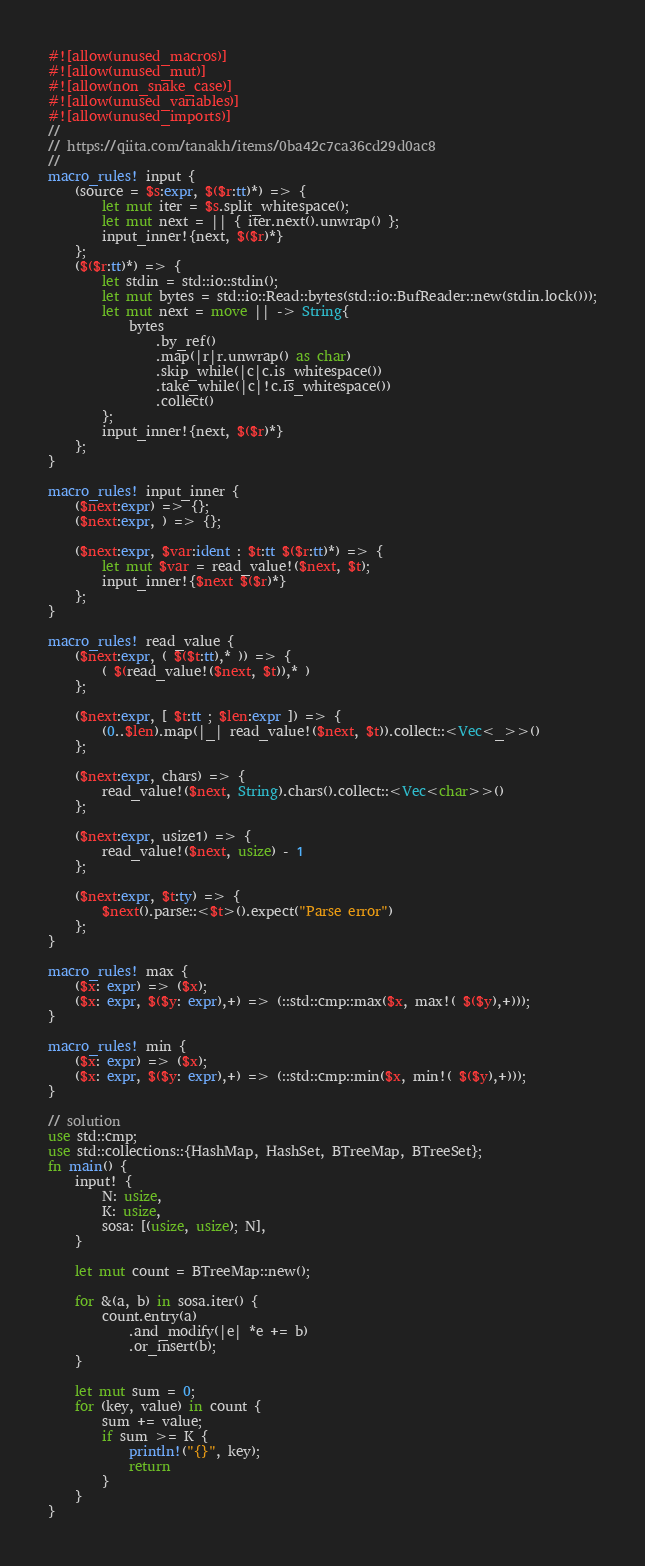<code> <loc_0><loc_0><loc_500><loc_500><_Rust_>#![allow(unused_macros)]
#![allow(unused_mut)]
#![allow(non_snake_case)]
#![allow(unused_variables)]
#![allow(unused_imports)]
//
// https://qiita.com/tanakh/items/0ba42c7ca36cd29d0ac8
//
macro_rules! input {
    (source = $s:expr, $($r:tt)*) => {
        let mut iter = $s.split_whitespace();
        let mut next = || { iter.next().unwrap() };
        input_inner!{next, $($r)*}
    };
    ($($r:tt)*) => {
        let stdin = std::io::stdin();
        let mut bytes = std::io::Read::bytes(std::io::BufReader::new(stdin.lock()));
        let mut next = move || -> String{
            bytes
                .by_ref()
                .map(|r|r.unwrap() as char)
                .skip_while(|c|c.is_whitespace())
                .take_while(|c|!c.is_whitespace())
                .collect()
        };
        input_inner!{next, $($r)*}
    };
}

macro_rules! input_inner {
    ($next:expr) => {};
    ($next:expr, ) => {};

    ($next:expr, $var:ident : $t:tt $($r:tt)*) => {
        let mut $var = read_value!($next, $t);
        input_inner!{$next $($r)*}
    };
}

macro_rules! read_value {
    ($next:expr, ( $($t:tt),* )) => {
        ( $(read_value!($next, $t)),* )
    };

    ($next:expr, [ $t:tt ; $len:expr ]) => {
        (0..$len).map(|_| read_value!($next, $t)).collect::<Vec<_>>()
    };

    ($next:expr, chars) => {
        read_value!($next, String).chars().collect::<Vec<char>>()
    };

    ($next:expr, usize1) => {
        read_value!($next, usize) - 1
    };

    ($next:expr, $t:ty) => {
        $next().parse::<$t>().expect("Parse error")
    };
}

macro_rules! max {
    ($x: expr) => ($x);
    ($x: expr, $($y: expr),+) => (::std::cmp::max($x, max!( $($y),+)));
}

macro_rules! min {
    ($x: expr) => ($x);
    ($x: expr, $($y: expr),+) => (::std::cmp::min($x, min!( $($y),+)));
}

// solution 
use std::cmp;
use std::collections::{HashMap, HashSet, BTreeMap, BTreeSet};
fn main() {
    input! {
        N: usize,
        K: usize,
        sosa: [(usize, usize); N],
    }

    let mut count = BTreeMap::new();

    for &(a, b) in sosa.iter() {
        count.entry(a)
            .and_modify(|e| *e += b)
            .or_insert(b);
    }

    let mut sum = 0;
    for (key, value) in count {
        sum += value;
        if sum >= K {
            println!("{}", key);
            return
        }
    }
}
</code> 